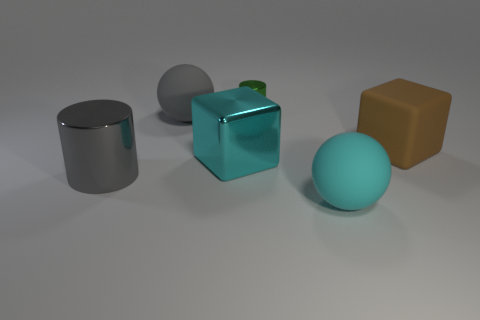There is a big cyan matte object; is its shape the same as the large rubber thing that is behind the big brown rubber thing?
Your response must be concise. Yes. The object that is both behind the large brown cube and left of the green thing is what color?
Provide a succinct answer. Gray. There is a large gray object that is in front of the large thing that is on the right side of the ball that is right of the tiny shiny cylinder; what is its material?
Your answer should be compact. Metal. What is the material of the cyan block?
Keep it short and to the point. Metal. There is a brown matte thing that is the same shape as the big cyan shiny object; what size is it?
Provide a short and direct response. Large. Is the large matte cube the same color as the large metallic cylinder?
Keep it short and to the point. No. How many other things are the same material as the big gray ball?
Provide a short and direct response. 2. Are there an equal number of big brown blocks right of the large matte cube and cyan metal cubes?
Your answer should be compact. No. There is a rubber cube behind the gray metallic cylinder; is it the same size as the green thing?
Offer a terse response. No. There is a large matte cube; how many big brown matte things are to the right of it?
Keep it short and to the point. 0. 